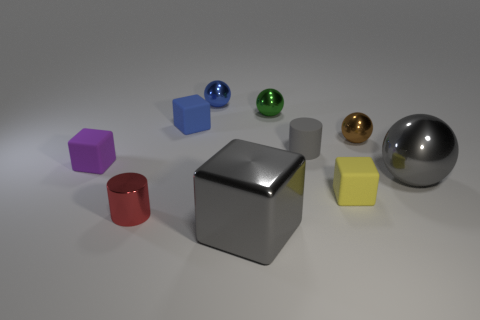Are there fewer big brown objects than tiny blue objects?
Your answer should be very brief. Yes. Does the matte object to the left of the blue matte thing have the same size as the gray metallic thing behind the tiny shiny cylinder?
Provide a short and direct response. No. How many brown things are either balls or small blocks?
Your answer should be compact. 1. There is a shiny sphere that is the same color as the big block; what is its size?
Provide a succinct answer. Large. Is the number of red metal cylinders greater than the number of shiny spheres?
Ensure brevity in your answer.  No. Is the small shiny cylinder the same color as the shiny cube?
Offer a very short reply. No. How many objects are either big gray metal cubes or small rubber blocks in front of the small gray rubber thing?
Your response must be concise. 3. How many other objects are the same shape as the tiny green metal thing?
Provide a succinct answer. 3. Is the number of blue metallic balls on the right side of the large gray shiny ball less than the number of tiny cylinders that are to the right of the small red cylinder?
Keep it short and to the point. Yes. Are there any other things that have the same material as the big block?
Ensure brevity in your answer.  Yes. 